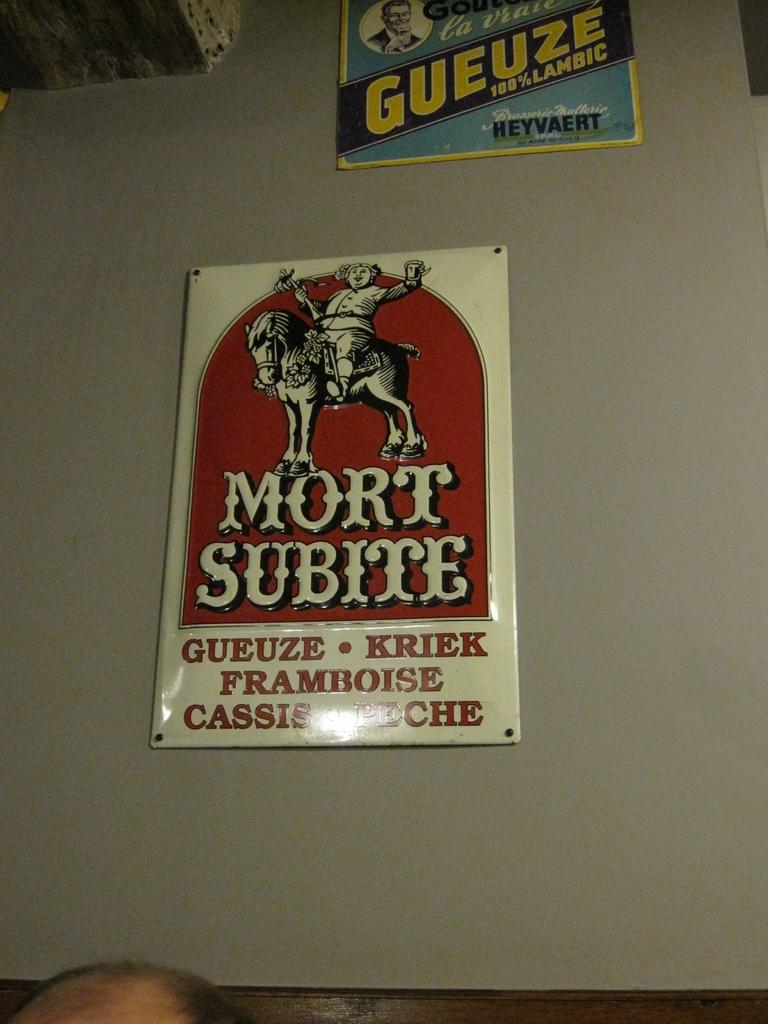What is featured on the poster in the image? The poster contains an animated person and an animated horse. What else can be seen on the poster besides the animated characters? There is printed text on the poster. Can you describe the human head visible in the image? A human head is visible in the image, but its features or context are not clear from the provided facts. How does the wind affect the power of the animated horse in the image? There is no mention of wind or power in the image, and the animated horse is not shown to be affected by any external factors. 